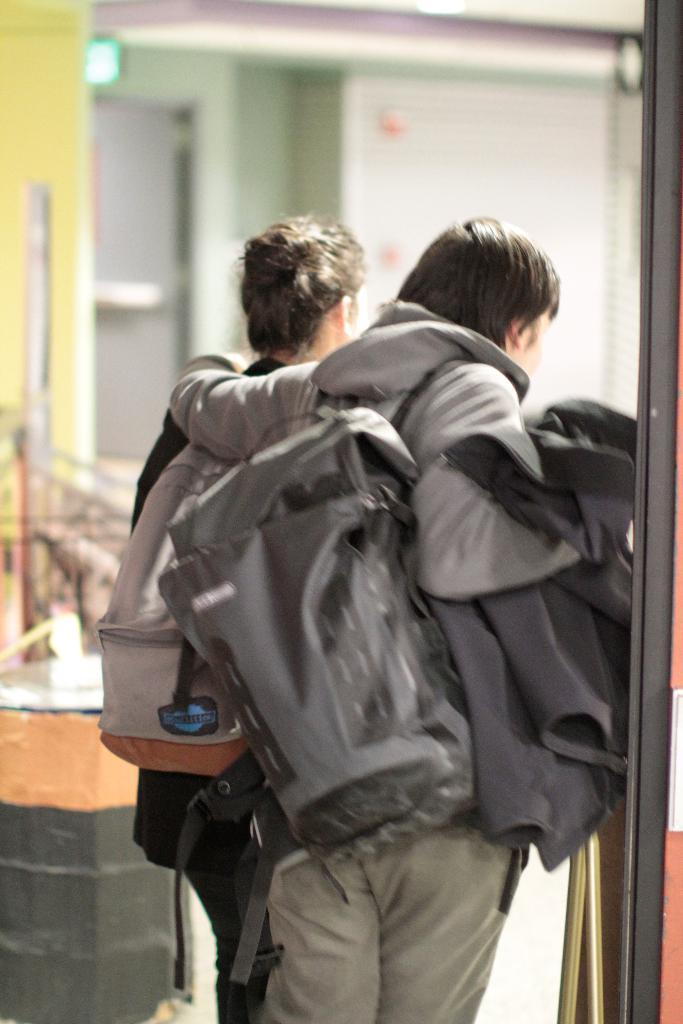How many people are in the image? There are two persons in the image. What are the persons doing in the image? The persons are standing. What are the persons wearing that is visible in the image? The persons are wearing bags. What can be seen in the background of the image? There is a wall and a door in the background of the image. What type of mass can be seen moving along the rail in the image? There is no mass or rail present in the image. What sound can be heard coming from the door in the image? The image is a still image, so no sound can be heard. 